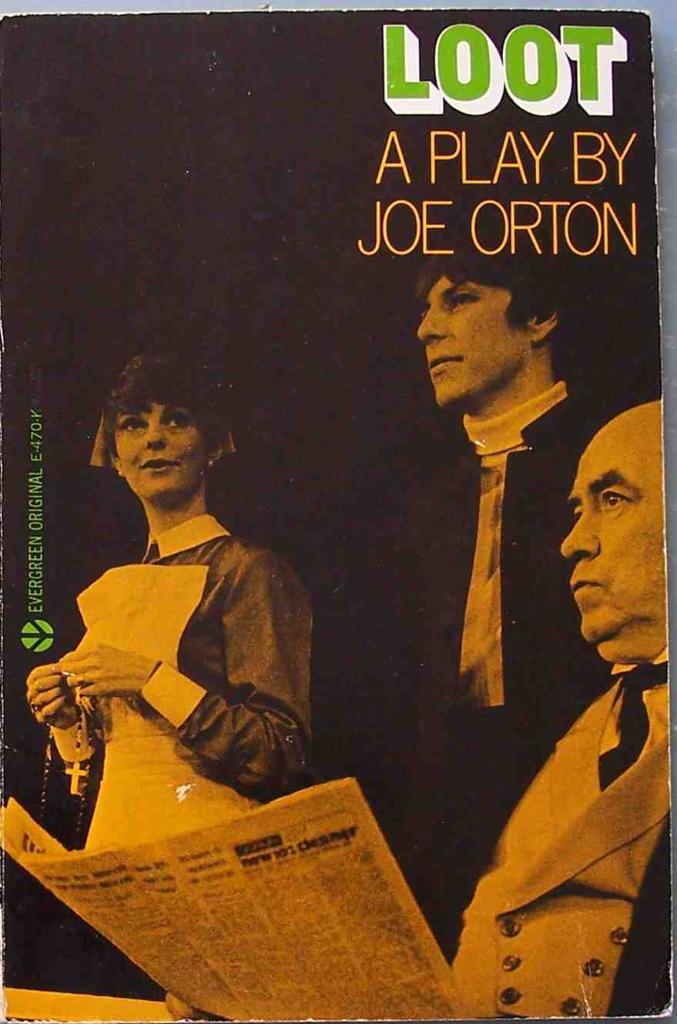Who is the author?
Give a very brief answer. Joe orton. What is the play called?
Provide a short and direct response. Loot. 